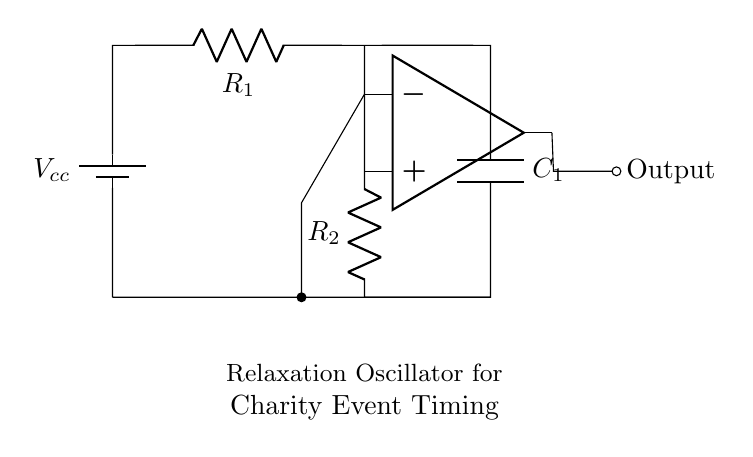what type of components are shown in the circuit? The circuit includes a battery, resistors, a capacitor, and an operational amplifier. These components are essential for the operation of the relaxation oscillator.
Answer: battery, resistors, capacitor, operational amplifier what is the function of the capacitor in this circuit? The capacitor stores and releases electrical energy, which helps to control the timing of the output pulses generated by the oscillator. The charging and discharging of the capacitor lead to the oscillatory behavior of the circuit.
Answer: timing control how many resistors are present in the circuit? There are two resistors, labeled R1 and R2, that form part of the oscillator circuit, each playing a role in determining the timing characteristics of the pulses.
Answer: 2 what determines the frequency of the oscillator circuit? The frequency is influenced by the values of the resistors (R1 and R2) and the capacitor (C1). This relationship can be described by the formula for oscillation frequency in a relaxation oscillator.
Answer: R1, R2, C1 why is an operational amplifier used in this circuit? An operational amplifier is used to provide sufficient gain and to create the necessary feedback loop, which is crucial for the oscillation process in generating output pulses. Without it, the desired pulse generation may not be achieved.
Answer: gain and feedback what is the output of the oscillator circuit? The output is a sequence of pulses generated by the circuit, which can be used for timing devices in charity event management. The output is indicated at the point where the line is marked "Output."
Answer: pulses how can this circuit be utilized in charity event management? The circuit can be used to create timing signals for various activities during charity events, such as race timings or countdowns, ensuring smooth coordination and management of event schedules.
Answer: timing signals 